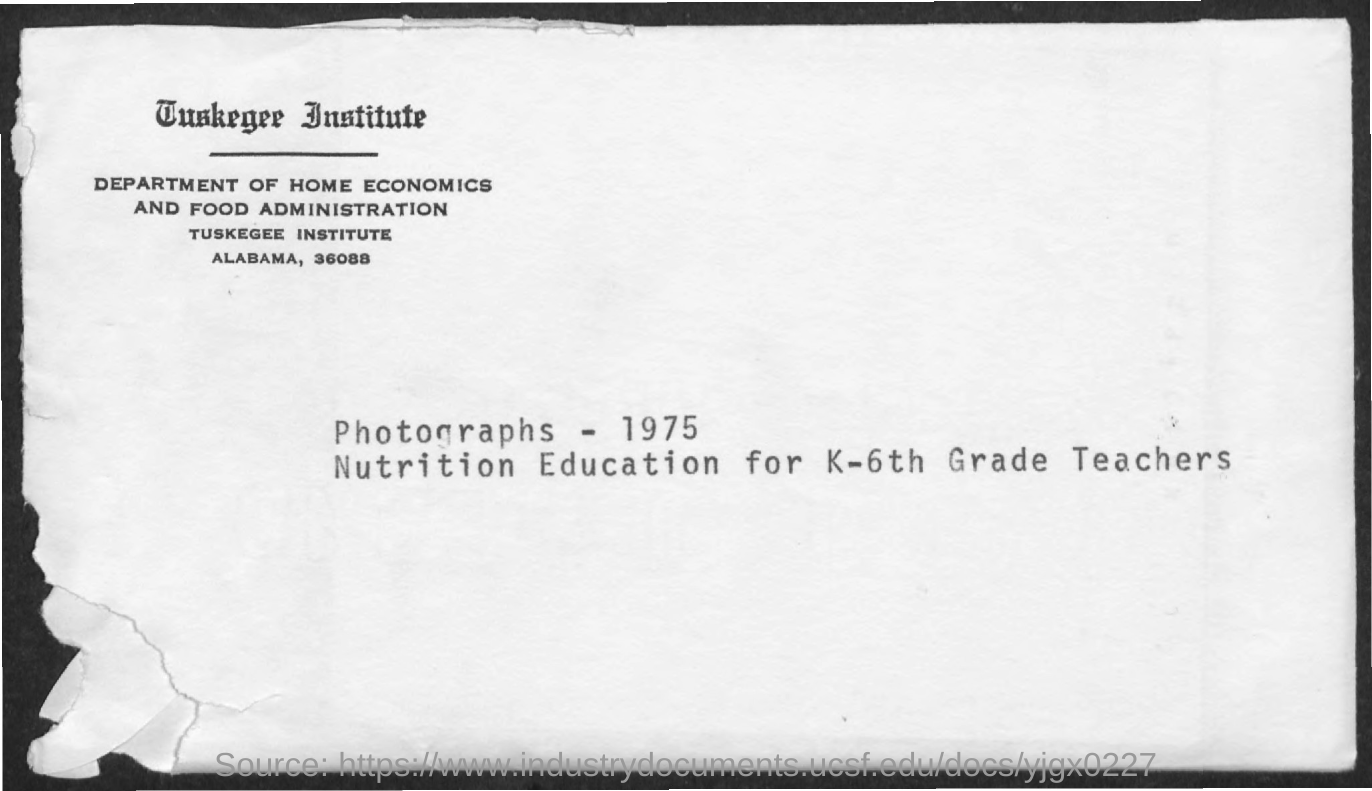Indicate a few pertinent items in this graphic. There were 1975 photographs mentioned. The Department of Home Economics and Food Administration is known as "DEPARTMENT OF HOME ECONOMICS AND FOOD ADMINISTRATION. 